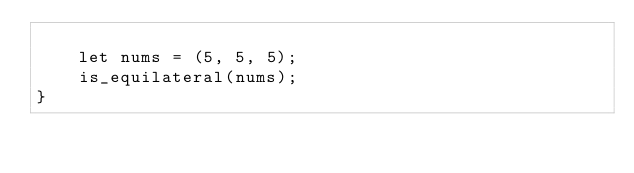<code> <loc_0><loc_0><loc_500><loc_500><_Rust_>
    let nums = (5, 5, 5);
    is_equilateral(nums);
}
</code> 